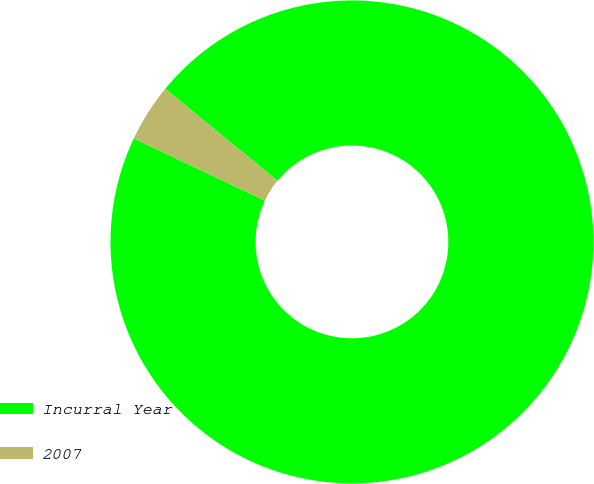Convert chart to OTSL. <chart><loc_0><loc_0><loc_500><loc_500><pie_chart><fcel>Incurral Year<fcel>2007<nl><fcel>96.12%<fcel>3.88%<nl></chart> 